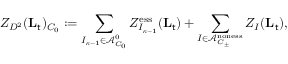Convert formula to latex. <formula><loc_0><loc_0><loc_500><loc_500>Z _ { D ^ { 2 } } ( L _ { t } ) _ { C _ { 0 } } \colon = \sum _ { I _ { { \kappa } - 1 } \in \mathcal { A } _ { C _ { 0 } } ^ { 0 } } Z _ { I _ { { \kappa } - 1 } } ^ { e s s } ( L _ { t } ) + \sum _ { I \in \mathcal { A } _ { C _ { \pm } } ^ { n o n e s s } } Z _ { I } ( L _ { t } ) ,</formula> 